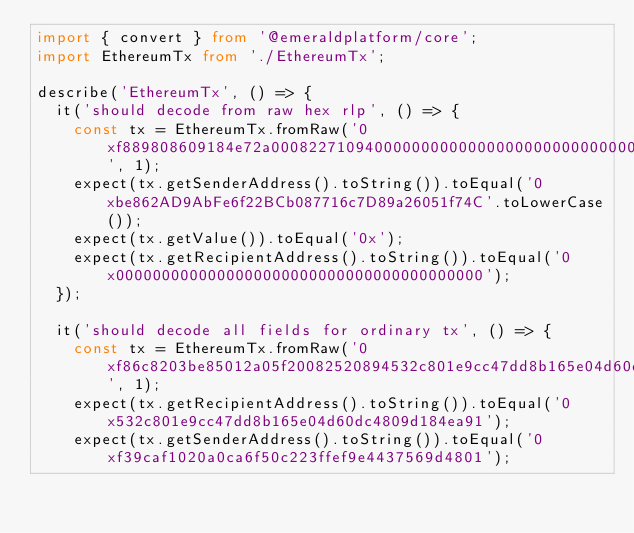Convert code to text. <code><loc_0><loc_0><loc_500><loc_500><_TypeScript_>import { convert } from '@emeraldplatform/core';
import EthereumTx from './EthereumTx';

describe('EthereumTx', () => {
  it('should decode from raw hex rlp', () => {
    const tx = EthereumTx.fromRaw('0xf889808609184e72a00082271094000000000000000000000000000000000000000080a47f74657374320000000000000000000000000000000000000000000000000000006000571ca08a8bbf888cfa37bbf0bb965423625641fc956967b81d12e23709cead01446075a01ce999b56a8a88504be365442ea61239198e23d1fce7d00fcfc5cd3b44b7215f', 1);
    expect(tx.getSenderAddress().toString()).toEqual('0xbe862AD9AbFe6f22BCb087716c7D89a26051f74C'.toLowerCase());
    expect(tx.getValue()).toEqual('0x');
    expect(tx.getRecipientAddress().toString()).toEqual('0x0000000000000000000000000000000000000000');
  });

  it('should decode all fields for ordinary tx', () => {
    const tx = EthereumTx.fromRaw('0xf86c8203be85012a05f20082520894532c801e9cc47dd8b165e04d60dc4809d184ea9186c724990520008026a0757a98c3e116bf1dc3f0b2e6d6c5d42cd5e3bd7edb8385b7e31acc6aac1d67afa0616c169a9297bc04cec57be60184d9c8f524e6768a9395475548851572e031e9', 1);
    expect(tx.getRecipientAddress().toString()).toEqual('0x532c801e9cc47dd8b165e04d60dc4809d184ea91');
    expect(tx.getSenderAddress().toString()).toEqual('0xf39caf1020a0ca6f50c223ffef9e4437569d4801');</code> 